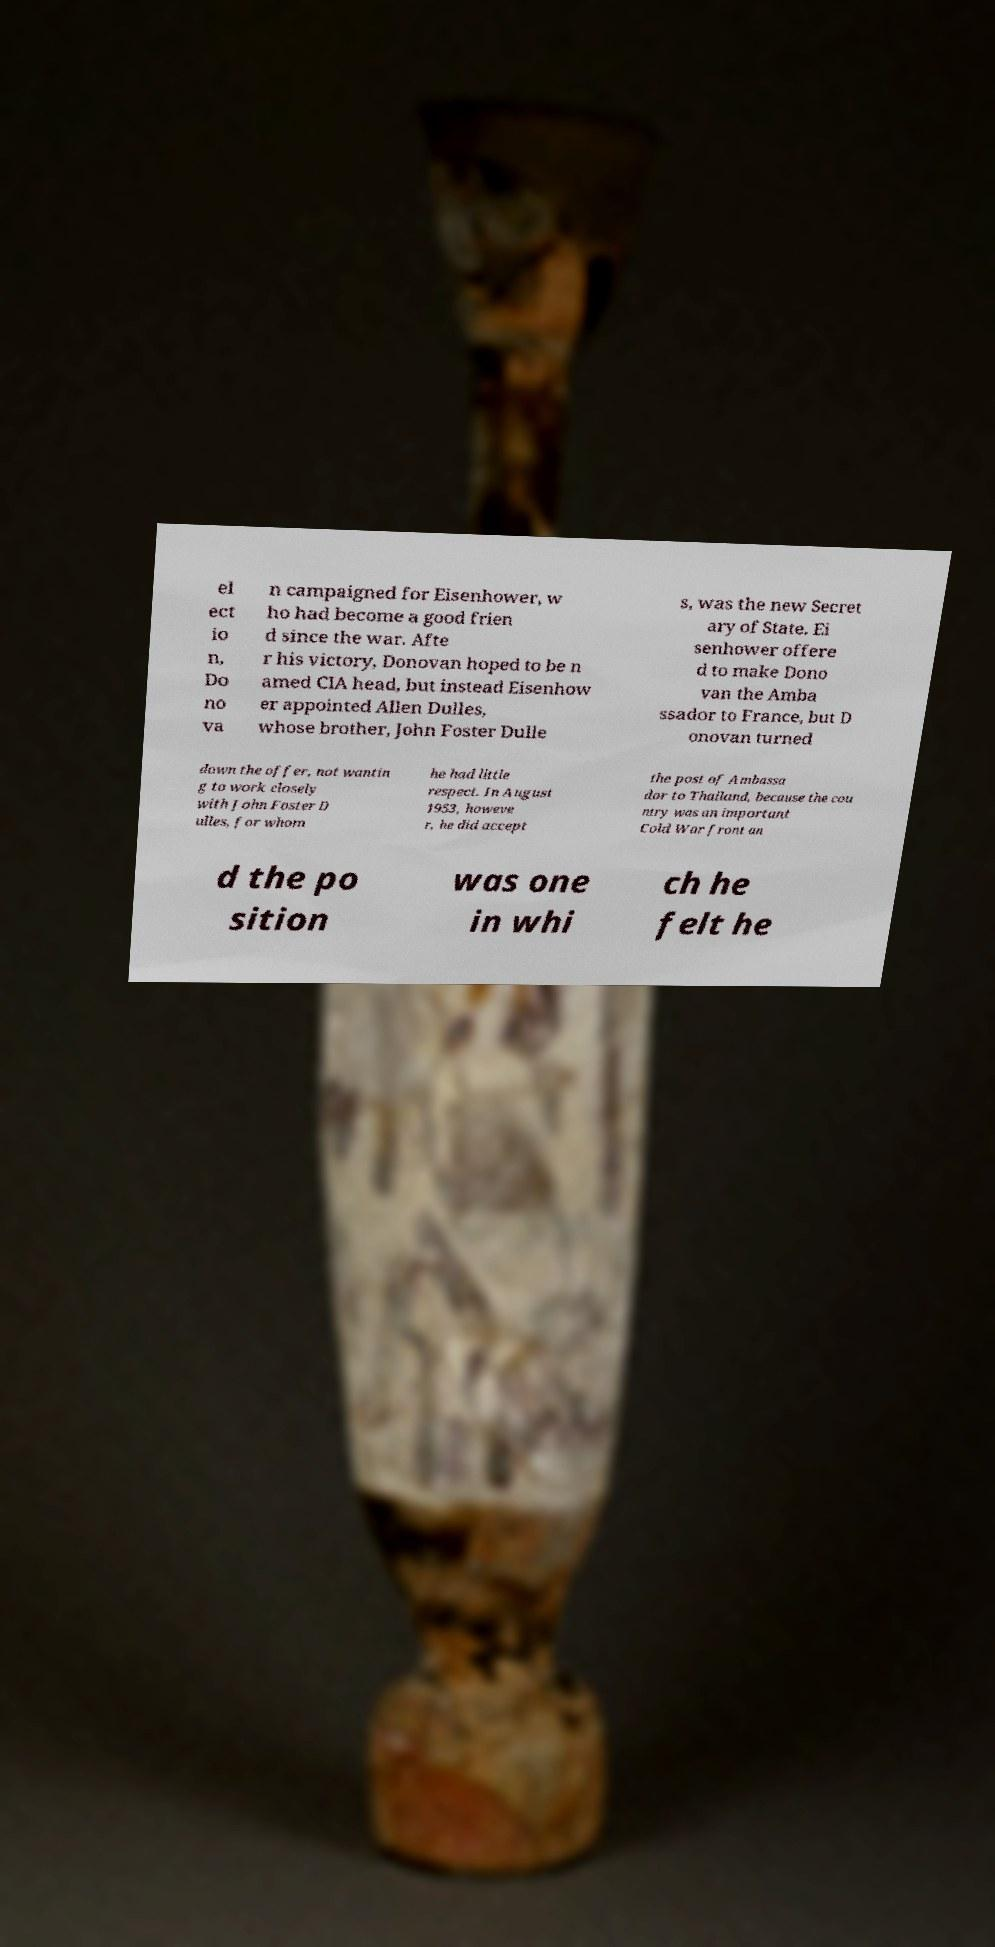I need the written content from this picture converted into text. Can you do that? el ect io n, Do no va n campaigned for Eisenhower, w ho had become a good frien d since the war. Afte r his victory, Donovan hoped to be n amed CIA head, but instead Eisenhow er appointed Allen Dulles, whose brother, John Foster Dulle s, was the new Secret ary of State. Ei senhower offere d to make Dono van the Amba ssador to France, but D onovan turned down the offer, not wantin g to work closely with John Foster D ulles, for whom he had little respect. In August 1953, howeve r, he did accept the post of Ambassa dor to Thailand, because the cou ntry was an important Cold War front an d the po sition was one in whi ch he felt he 